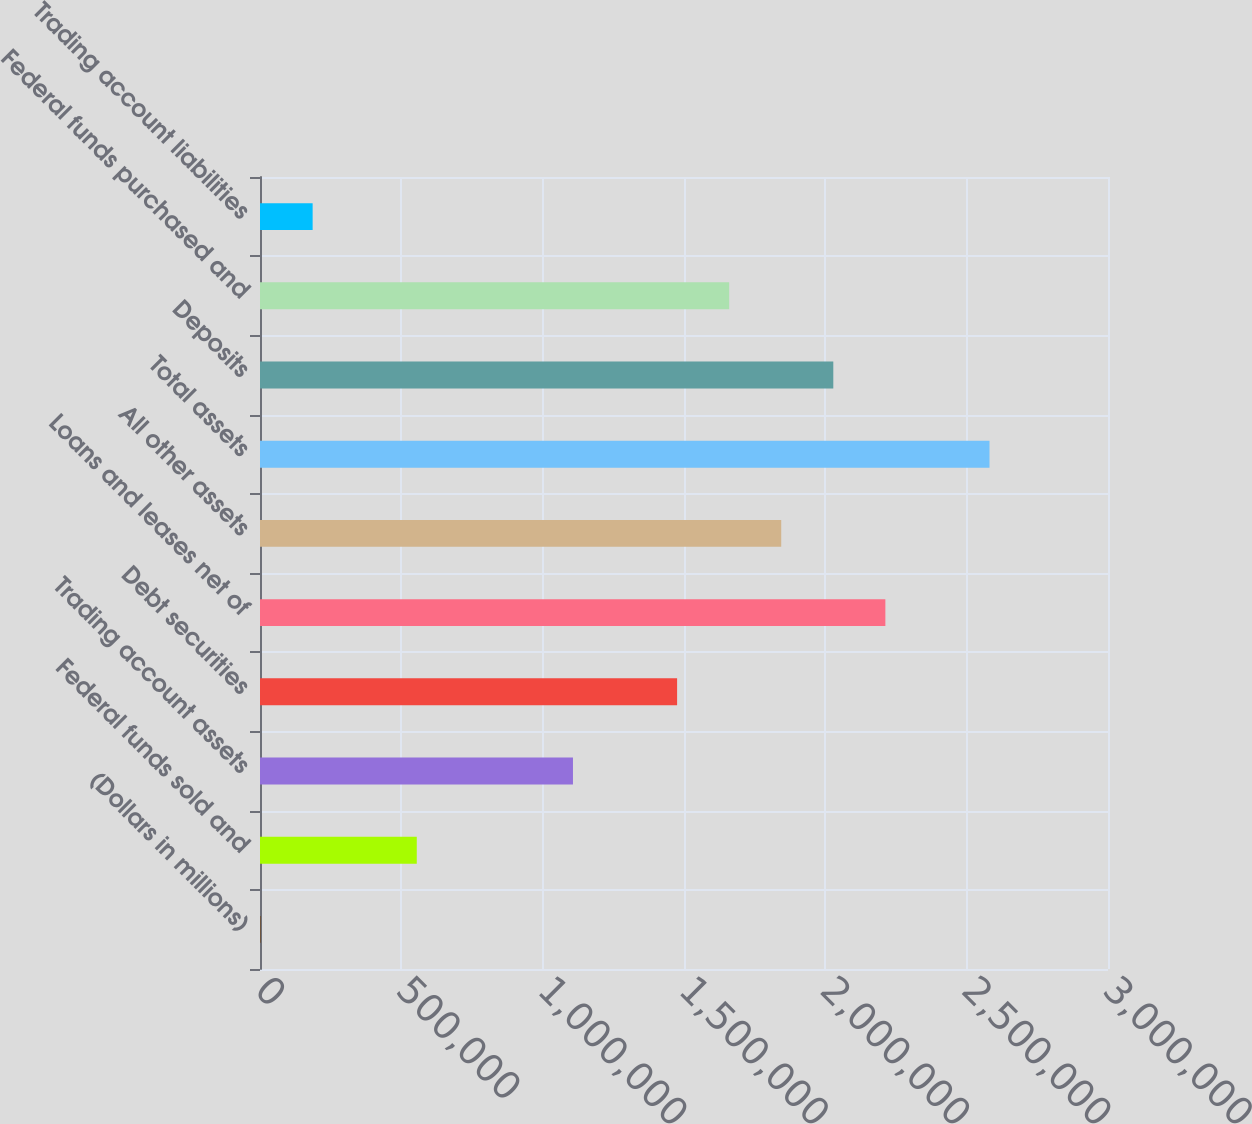Convert chart. <chart><loc_0><loc_0><loc_500><loc_500><bar_chart><fcel>(Dollars in millions)<fcel>Federal funds sold and<fcel>Trading account assets<fcel>Debt securities<fcel>Loans and leases net of<fcel>All other assets<fcel>Total assets<fcel>Deposits<fcel>Federal funds purchased and<fcel>Trading account liabilities<nl><fcel>2008<fcel>554599<fcel>1.10719e+06<fcel>1.47558e+06<fcel>2.21237e+06<fcel>1.84398e+06<fcel>2.58077e+06<fcel>2.02818e+06<fcel>1.65978e+06<fcel>186205<nl></chart> 